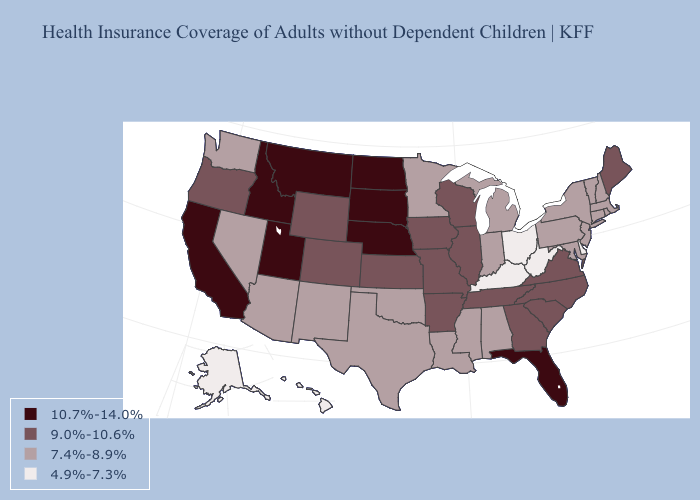Which states have the lowest value in the South?
Quick response, please. Delaware, Kentucky, West Virginia. What is the value of Kansas?
Answer briefly. 9.0%-10.6%. Name the states that have a value in the range 9.0%-10.6%?
Answer briefly. Arkansas, Colorado, Georgia, Illinois, Iowa, Kansas, Maine, Missouri, North Carolina, Oregon, South Carolina, Tennessee, Virginia, Wisconsin, Wyoming. What is the value of Indiana?
Keep it brief. 7.4%-8.9%. What is the highest value in states that border West Virginia?
Write a very short answer. 9.0%-10.6%. Is the legend a continuous bar?
Write a very short answer. No. Among the states that border Florida , which have the lowest value?
Keep it brief. Alabama. Name the states that have a value in the range 7.4%-8.9%?
Keep it brief. Alabama, Arizona, Connecticut, Indiana, Louisiana, Maryland, Massachusetts, Michigan, Minnesota, Mississippi, Nevada, New Hampshire, New Jersey, New Mexico, New York, Oklahoma, Pennsylvania, Rhode Island, Texas, Vermont, Washington. What is the value of North Carolina?
Give a very brief answer. 9.0%-10.6%. Is the legend a continuous bar?
Quick response, please. No. What is the lowest value in the South?
Be succinct. 4.9%-7.3%. Does New Jersey have the lowest value in the Northeast?
Quick response, please. Yes. Which states have the lowest value in the USA?
Concise answer only. Alaska, Delaware, Hawaii, Kentucky, Ohio, West Virginia. Name the states that have a value in the range 4.9%-7.3%?
Concise answer only. Alaska, Delaware, Hawaii, Kentucky, Ohio, West Virginia. Which states have the lowest value in the USA?
Quick response, please. Alaska, Delaware, Hawaii, Kentucky, Ohio, West Virginia. 